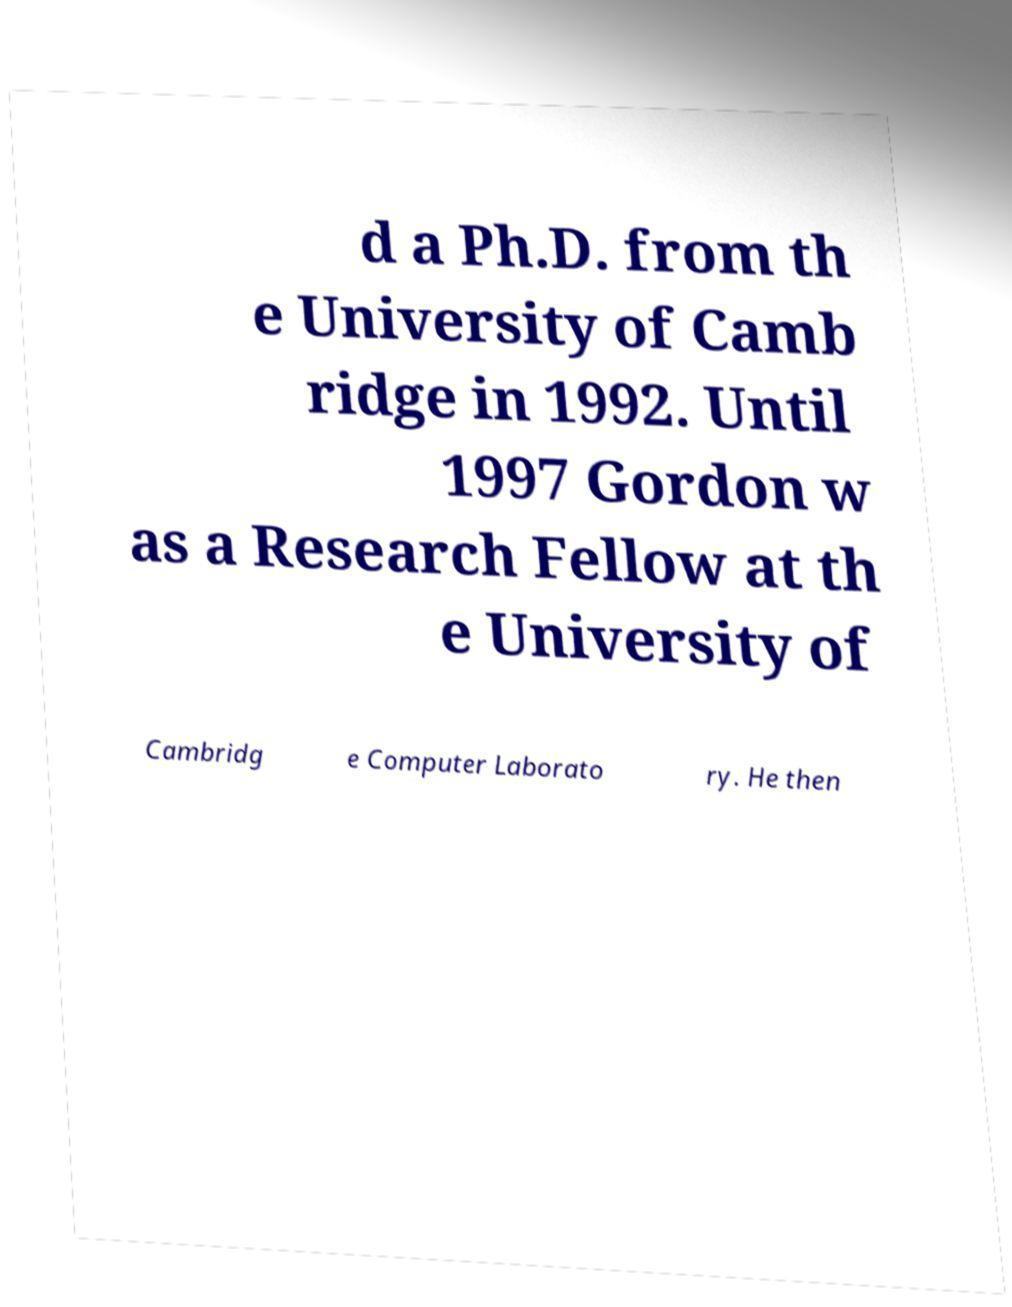For documentation purposes, I need the text within this image transcribed. Could you provide that? d a Ph.D. from th e University of Camb ridge in 1992. Until 1997 Gordon w as a Research Fellow at th e University of Cambridg e Computer Laborato ry. He then 